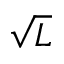<formula> <loc_0><loc_0><loc_500><loc_500>\sqrt { L }</formula> 